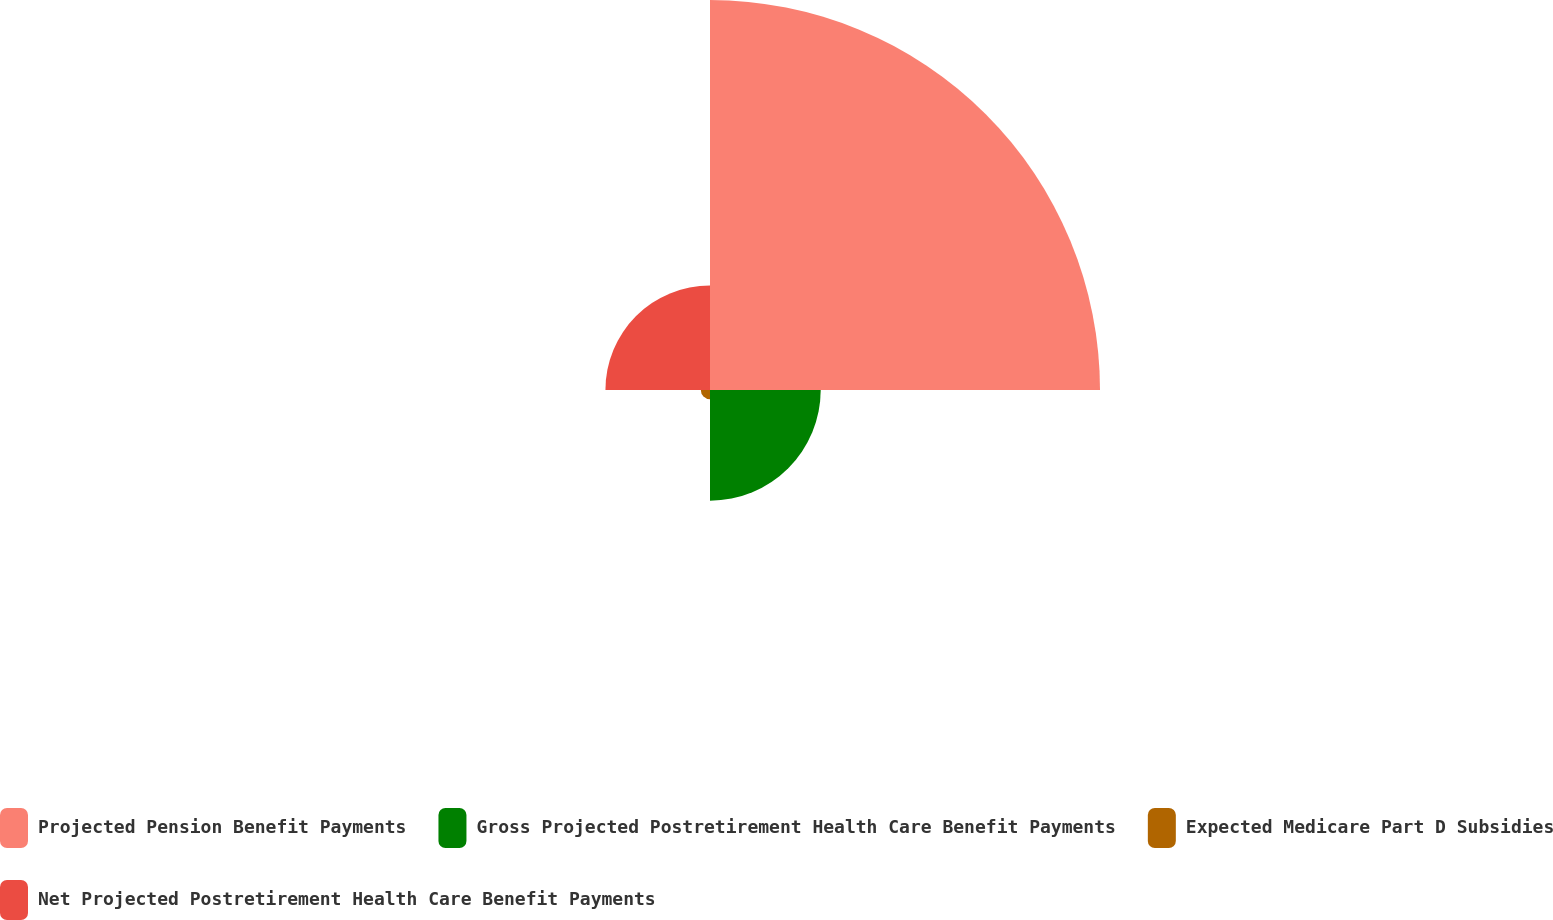<chart> <loc_0><loc_0><loc_500><loc_500><pie_chart><fcel>Projected Pension Benefit Payments<fcel>Gross Projected Postretirement Health Care Benefit Payments<fcel>Expected Medicare Part D Subsidies<fcel>Net Projected Postretirement Health Care Benefit Payments<nl><fcel>63.48%<fcel>18.02%<fcel>1.49%<fcel>17.02%<nl></chart> 